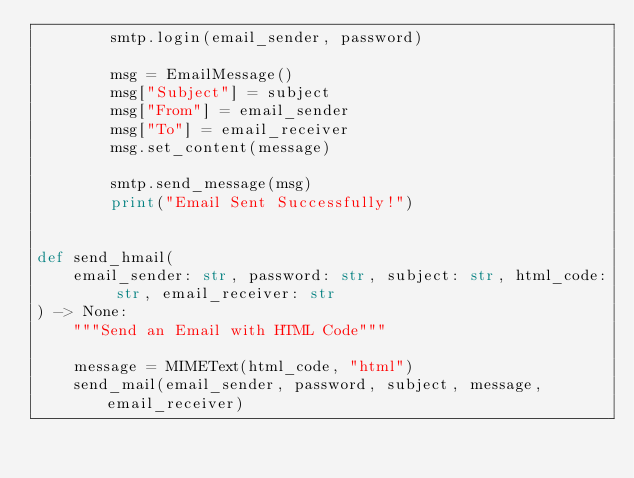Convert code to text. <code><loc_0><loc_0><loc_500><loc_500><_Python_>        smtp.login(email_sender, password)

        msg = EmailMessage()
        msg["Subject"] = subject
        msg["From"] = email_sender
        msg["To"] = email_receiver
        msg.set_content(message)

        smtp.send_message(msg)
        print("Email Sent Successfully!")


def send_hmail(
    email_sender: str, password: str, subject: str, html_code: str, email_receiver: str
) -> None:
    """Send an Email with HTML Code"""

    message = MIMEText(html_code, "html")
    send_mail(email_sender, password, subject, message, email_receiver)
</code> 